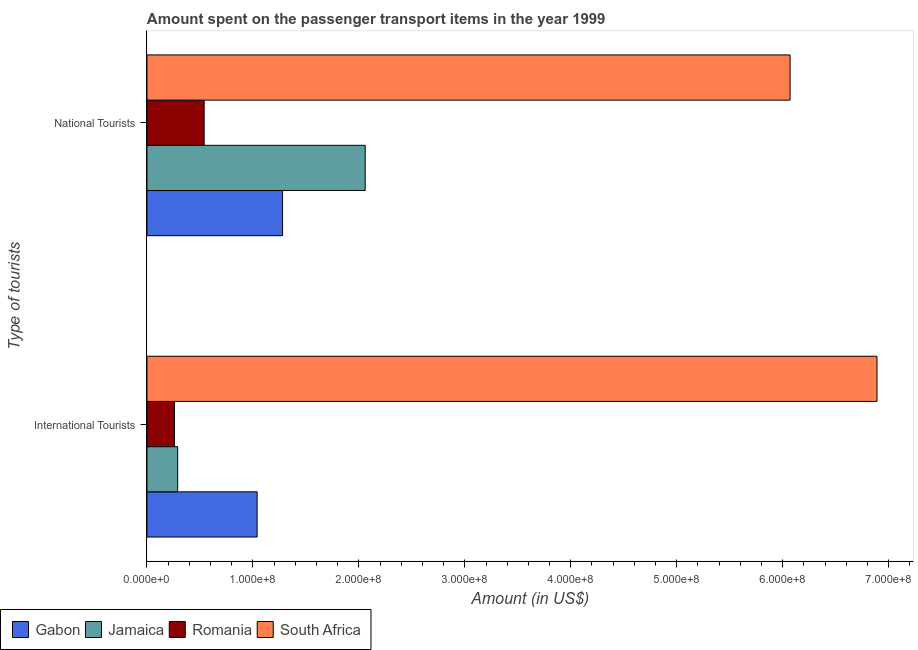How many different coloured bars are there?
Provide a short and direct response. 4. Are the number of bars on each tick of the Y-axis equal?
Make the answer very short. Yes. What is the label of the 1st group of bars from the top?
Your answer should be very brief. National Tourists. What is the amount spent on transport items of national tourists in Gabon?
Give a very brief answer. 1.28e+08. Across all countries, what is the maximum amount spent on transport items of international tourists?
Offer a very short reply. 6.89e+08. Across all countries, what is the minimum amount spent on transport items of international tourists?
Keep it short and to the point. 2.60e+07. In which country was the amount spent on transport items of international tourists maximum?
Give a very brief answer. South Africa. In which country was the amount spent on transport items of national tourists minimum?
Offer a very short reply. Romania. What is the total amount spent on transport items of international tourists in the graph?
Your answer should be compact. 8.48e+08. What is the difference between the amount spent on transport items of national tourists in Jamaica and that in South Africa?
Make the answer very short. -4.01e+08. What is the difference between the amount spent on transport items of national tourists in Romania and the amount spent on transport items of international tourists in South Africa?
Your response must be concise. -6.35e+08. What is the average amount spent on transport items of national tourists per country?
Provide a succinct answer. 2.49e+08. What is the difference between the amount spent on transport items of international tourists and amount spent on transport items of national tourists in Jamaica?
Keep it short and to the point. -1.77e+08. What is the ratio of the amount spent on transport items of international tourists in Jamaica to that in South Africa?
Your answer should be very brief. 0.04. What does the 3rd bar from the top in International Tourists represents?
Offer a very short reply. Jamaica. What does the 3rd bar from the bottom in International Tourists represents?
Offer a very short reply. Romania. How many countries are there in the graph?
Your answer should be very brief. 4. Does the graph contain grids?
Your answer should be very brief. No. Where does the legend appear in the graph?
Provide a short and direct response. Bottom left. How are the legend labels stacked?
Give a very brief answer. Horizontal. What is the title of the graph?
Provide a succinct answer. Amount spent on the passenger transport items in the year 1999. What is the label or title of the X-axis?
Ensure brevity in your answer.  Amount (in US$). What is the label or title of the Y-axis?
Your answer should be very brief. Type of tourists. What is the Amount (in US$) of Gabon in International Tourists?
Your response must be concise. 1.04e+08. What is the Amount (in US$) of Jamaica in International Tourists?
Keep it short and to the point. 2.90e+07. What is the Amount (in US$) in Romania in International Tourists?
Your response must be concise. 2.60e+07. What is the Amount (in US$) of South Africa in International Tourists?
Give a very brief answer. 6.89e+08. What is the Amount (in US$) of Gabon in National Tourists?
Provide a short and direct response. 1.28e+08. What is the Amount (in US$) in Jamaica in National Tourists?
Offer a terse response. 2.06e+08. What is the Amount (in US$) of Romania in National Tourists?
Ensure brevity in your answer.  5.40e+07. What is the Amount (in US$) of South Africa in National Tourists?
Offer a very short reply. 6.07e+08. Across all Type of tourists, what is the maximum Amount (in US$) in Gabon?
Make the answer very short. 1.28e+08. Across all Type of tourists, what is the maximum Amount (in US$) in Jamaica?
Your answer should be compact. 2.06e+08. Across all Type of tourists, what is the maximum Amount (in US$) in Romania?
Your answer should be compact. 5.40e+07. Across all Type of tourists, what is the maximum Amount (in US$) in South Africa?
Offer a very short reply. 6.89e+08. Across all Type of tourists, what is the minimum Amount (in US$) in Gabon?
Provide a succinct answer. 1.04e+08. Across all Type of tourists, what is the minimum Amount (in US$) in Jamaica?
Keep it short and to the point. 2.90e+07. Across all Type of tourists, what is the minimum Amount (in US$) of Romania?
Make the answer very short. 2.60e+07. Across all Type of tourists, what is the minimum Amount (in US$) of South Africa?
Keep it short and to the point. 6.07e+08. What is the total Amount (in US$) in Gabon in the graph?
Your answer should be very brief. 2.32e+08. What is the total Amount (in US$) in Jamaica in the graph?
Your answer should be compact. 2.35e+08. What is the total Amount (in US$) in Romania in the graph?
Provide a succinct answer. 8.00e+07. What is the total Amount (in US$) of South Africa in the graph?
Keep it short and to the point. 1.30e+09. What is the difference between the Amount (in US$) in Gabon in International Tourists and that in National Tourists?
Keep it short and to the point. -2.40e+07. What is the difference between the Amount (in US$) of Jamaica in International Tourists and that in National Tourists?
Ensure brevity in your answer.  -1.77e+08. What is the difference between the Amount (in US$) in Romania in International Tourists and that in National Tourists?
Offer a terse response. -2.80e+07. What is the difference between the Amount (in US$) in South Africa in International Tourists and that in National Tourists?
Ensure brevity in your answer.  8.20e+07. What is the difference between the Amount (in US$) of Gabon in International Tourists and the Amount (in US$) of Jamaica in National Tourists?
Your answer should be compact. -1.02e+08. What is the difference between the Amount (in US$) in Gabon in International Tourists and the Amount (in US$) in Romania in National Tourists?
Offer a terse response. 5.00e+07. What is the difference between the Amount (in US$) of Gabon in International Tourists and the Amount (in US$) of South Africa in National Tourists?
Offer a very short reply. -5.03e+08. What is the difference between the Amount (in US$) of Jamaica in International Tourists and the Amount (in US$) of Romania in National Tourists?
Your answer should be very brief. -2.50e+07. What is the difference between the Amount (in US$) of Jamaica in International Tourists and the Amount (in US$) of South Africa in National Tourists?
Your answer should be very brief. -5.78e+08. What is the difference between the Amount (in US$) of Romania in International Tourists and the Amount (in US$) of South Africa in National Tourists?
Give a very brief answer. -5.81e+08. What is the average Amount (in US$) of Gabon per Type of tourists?
Provide a succinct answer. 1.16e+08. What is the average Amount (in US$) in Jamaica per Type of tourists?
Provide a succinct answer. 1.18e+08. What is the average Amount (in US$) in Romania per Type of tourists?
Offer a very short reply. 4.00e+07. What is the average Amount (in US$) in South Africa per Type of tourists?
Keep it short and to the point. 6.48e+08. What is the difference between the Amount (in US$) of Gabon and Amount (in US$) of Jamaica in International Tourists?
Provide a succinct answer. 7.50e+07. What is the difference between the Amount (in US$) of Gabon and Amount (in US$) of Romania in International Tourists?
Give a very brief answer. 7.80e+07. What is the difference between the Amount (in US$) in Gabon and Amount (in US$) in South Africa in International Tourists?
Your answer should be compact. -5.85e+08. What is the difference between the Amount (in US$) in Jamaica and Amount (in US$) in South Africa in International Tourists?
Give a very brief answer. -6.60e+08. What is the difference between the Amount (in US$) in Romania and Amount (in US$) in South Africa in International Tourists?
Offer a terse response. -6.63e+08. What is the difference between the Amount (in US$) in Gabon and Amount (in US$) in Jamaica in National Tourists?
Offer a terse response. -7.80e+07. What is the difference between the Amount (in US$) in Gabon and Amount (in US$) in Romania in National Tourists?
Your answer should be very brief. 7.40e+07. What is the difference between the Amount (in US$) of Gabon and Amount (in US$) of South Africa in National Tourists?
Your answer should be compact. -4.79e+08. What is the difference between the Amount (in US$) in Jamaica and Amount (in US$) in Romania in National Tourists?
Provide a short and direct response. 1.52e+08. What is the difference between the Amount (in US$) of Jamaica and Amount (in US$) of South Africa in National Tourists?
Offer a terse response. -4.01e+08. What is the difference between the Amount (in US$) in Romania and Amount (in US$) in South Africa in National Tourists?
Your answer should be compact. -5.53e+08. What is the ratio of the Amount (in US$) of Gabon in International Tourists to that in National Tourists?
Keep it short and to the point. 0.81. What is the ratio of the Amount (in US$) of Jamaica in International Tourists to that in National Tourists?
Ensure brevity in your answer.  0.14. What is the ratio of the Amount (in US$) in Romania in International Tourists to that in National Tourists?
Make the answer very short. 0.48. What is the ratio of the Amount (in US$) of South Africa in International Tourists to that in National Tourists?
Your response must be concise. 1.14. What is the difference between the highest and the second highest Amount (in US$) in Gabon?
Provide a short and direct response. 2.40e+07. What is the difference between the highest and the second highest Amount (in US$) in Jamaica?
Ensure brevity in your answer.  1.77e+08. What is the difference between the highest and the second highest Amount (in US$) of Romania?
Ensure brevity in your answer.  2.80e+07. What is the difference between the highest and the second highest Amount (in US$) of South Africa?
Offer a terse response. 8.20e+07. What is the difference between the highest and the lowest Amount (in US$) of Gabon?
Keep it short and to the point. 2.40e+07. What is the difference between the highest and the lowest Amount (in US$) of Jamaica?
Provide a short and direct response. 1.77e+08. What is the difference between the highest and the lowest Amount (in US$) in Romania?
Your response must be concise. 2.80e+07. What is the difference between the highest and the lowest Amount (in US$) in South Africa?
Offer a very short reply. 8.20e+07. 